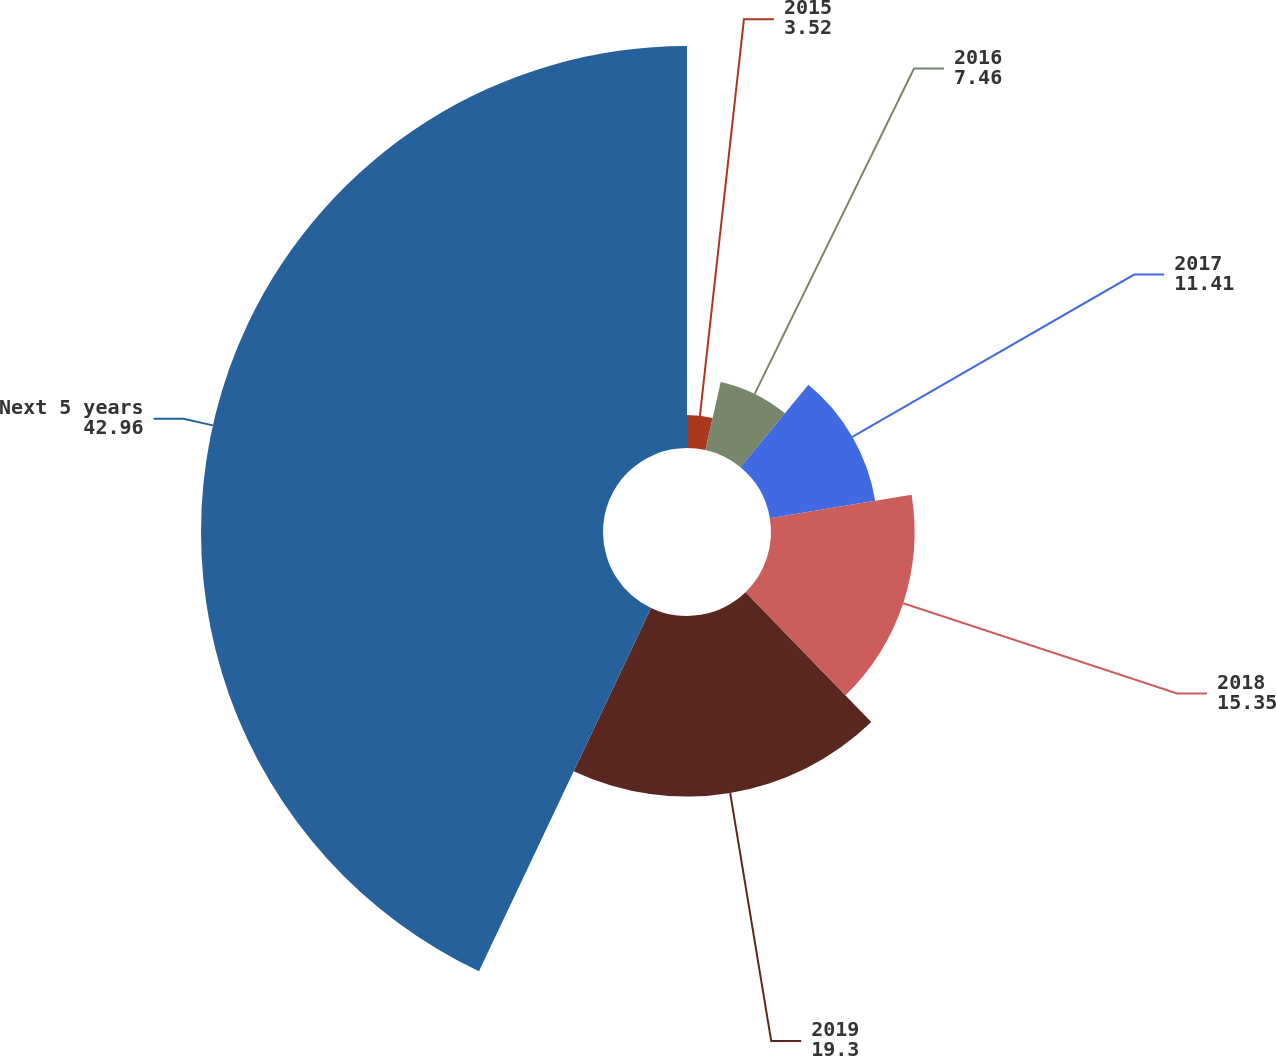Convert chart to OTSL. <chart><loc_0><loc_0><loc_500><loc_500><pie_chart><fcel>2015<fcel>2016<fcel>2017<fcel>2018<fcel>2019<fcel>Next 5 years<nl><fcel>3.52%<fcel>7.46%<fcel>11.41%<fcel>15.35%<fcel>19.3%<fcel>42.96%<nl></chart> 